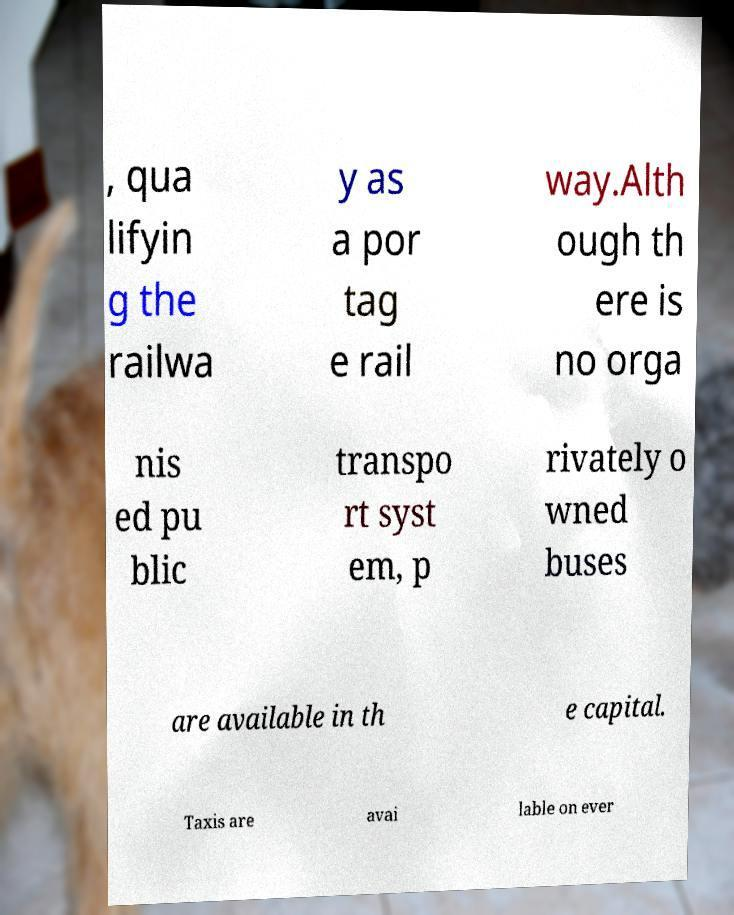There's text embedded in this image that I need extracted. Can you transcribe it verbatim? , qua lifyin g the railwa y as a por tag e rail way.Alth ough th ere is no orga nis ed pu blic transpo rt syst em, p rivately o wned buses are available in th e capital. Taxis are avai lable on ever 